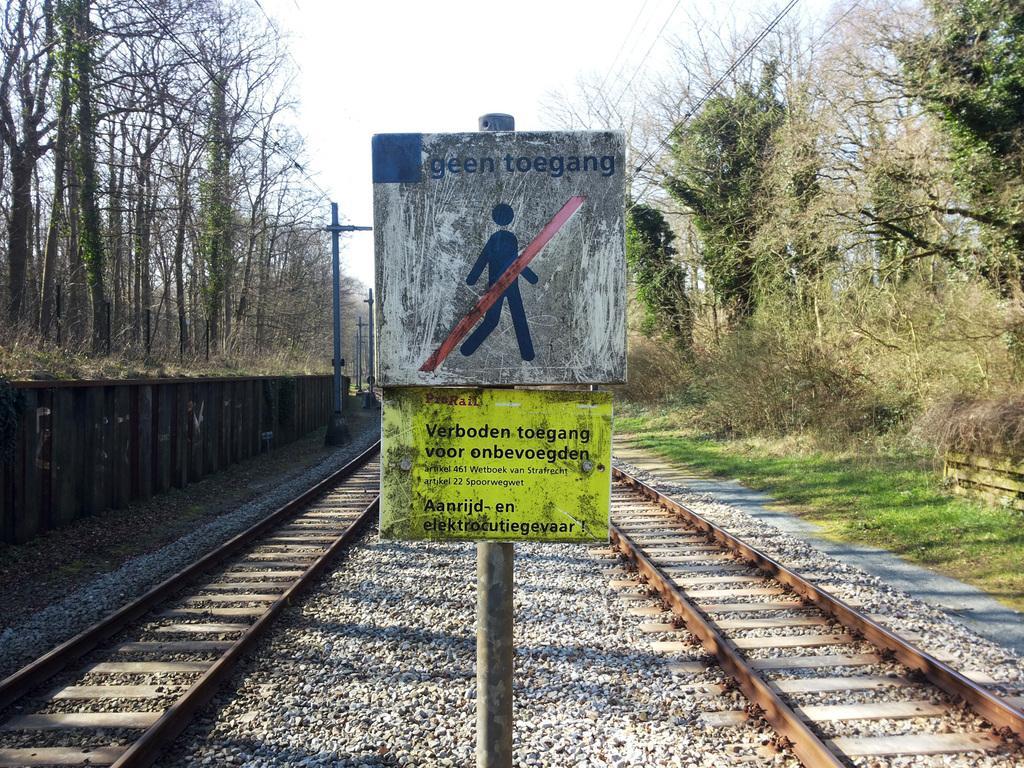Can you describe this image briefly? In this image we can see boards, poles, railway tracks and other objects. On the left and the right side of the image there are trees and cables. In the background of the image there is the sky. 